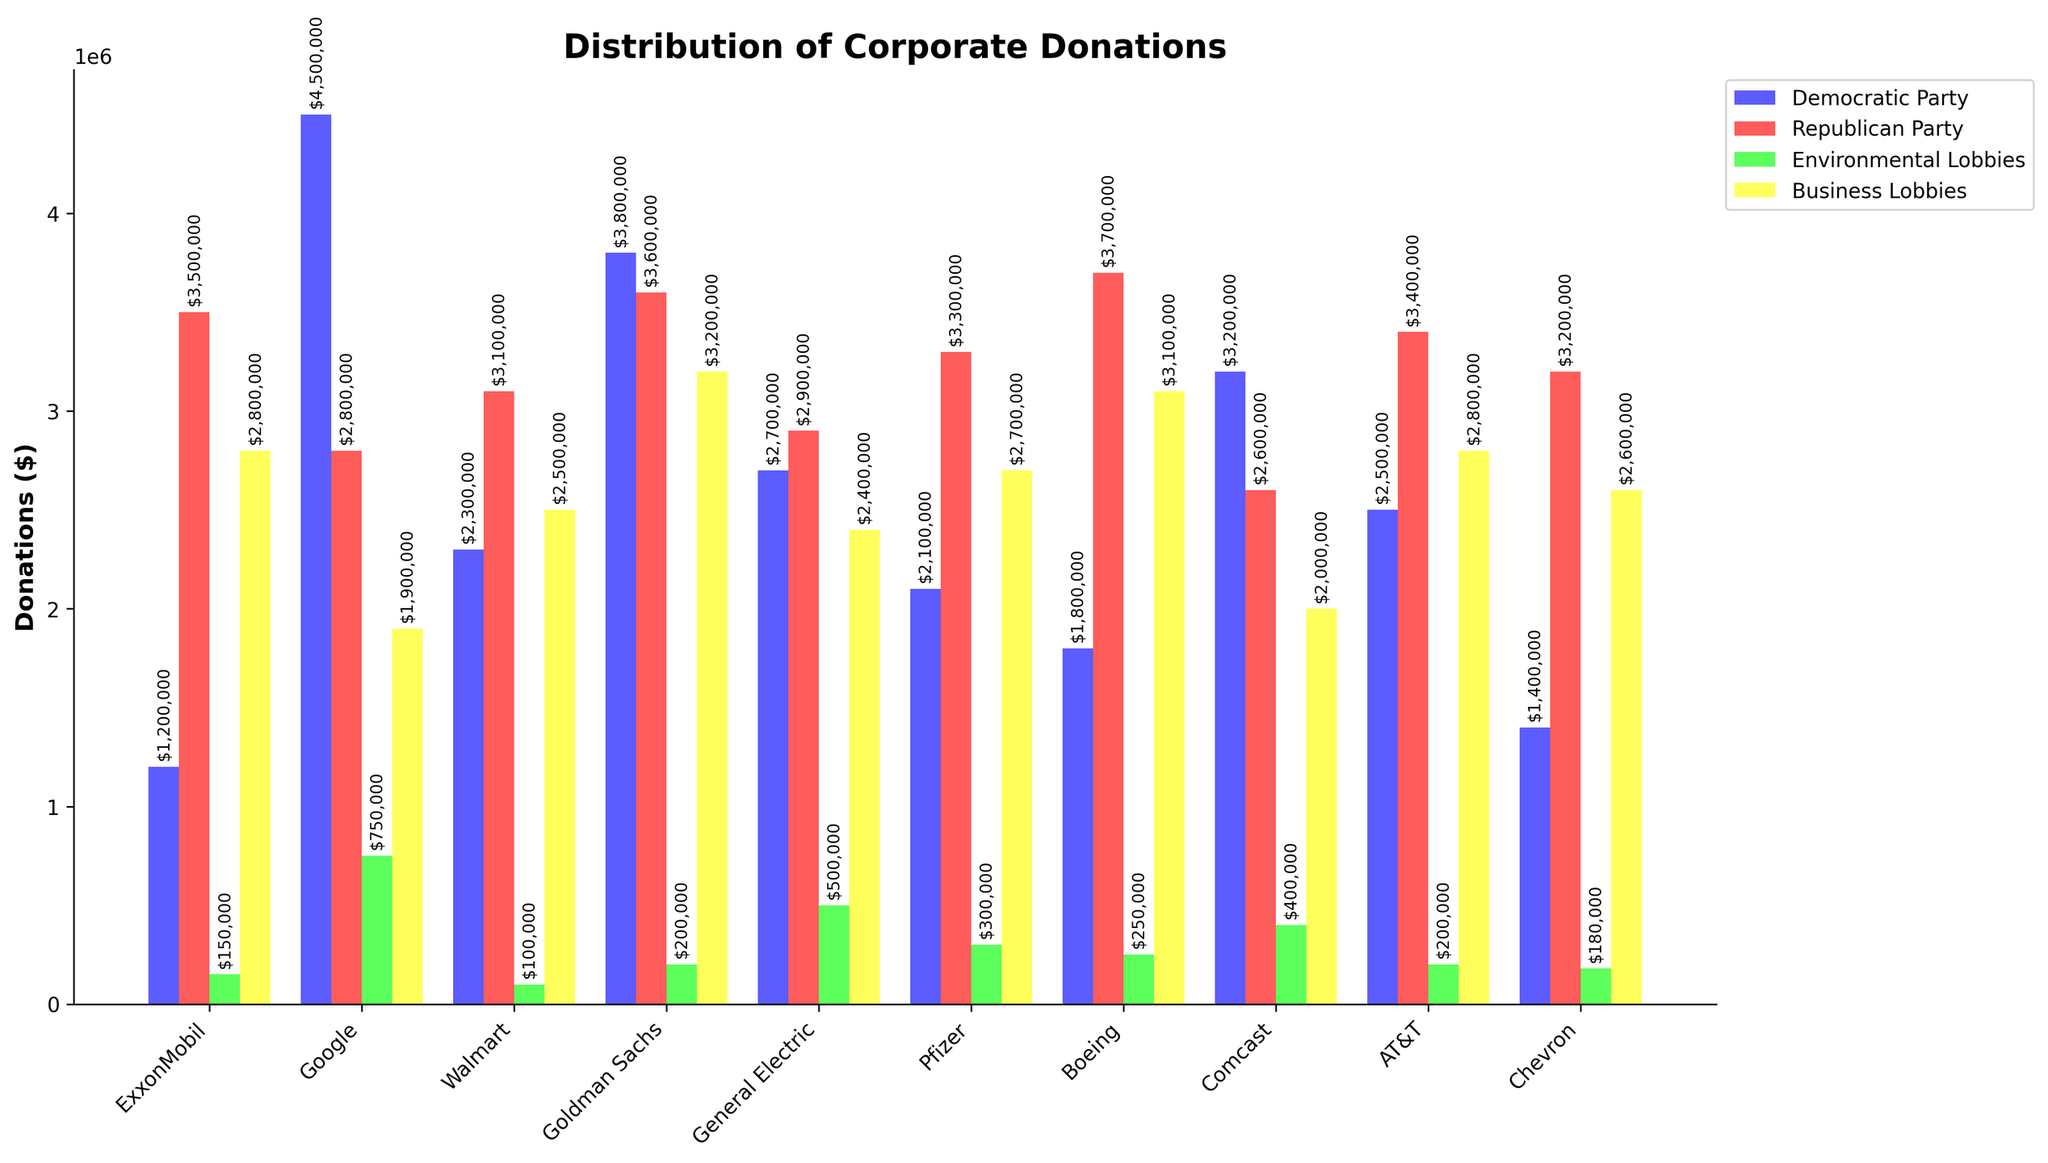What company donated the most to the Republican Party? Identify the bar corresponding to the "Republican Party" and compare their heights. The highest bar in this series belongs to Boeing.
Answer: Boeing Which company gave more to Business Lobbies compared to Democratic Party, and by how much? First, compare the heights of the bars for "Business Lobbies" and "Democratic Party" within each company. Then, calculate the difference where the "Business Lobbies" bar is taller. For AT&T: $2,800,000 (Business Lobbies) - $2,500,000 (Democratic Party) = $300,000.
Answer: AT&T, $300,000 What is the total donation amount that Google has made to all groups combined? Sum the heights of all bars corresponding to Google. $4,500,000 (Democratic Party) + $2,800,000 (Republican Party) + $750,000 (Environmental Lobbies) + $1,900,000 (Business Lobbies) = $9,950,000.
Answer: $9,950,000 Which company has the highest combined donation to Environmental Lobbies and Democratic Party? Sum the heights of the bars for "Environmental Lobbies" and "Democratic Party" for each company. The highest total is for Google: $4,500,000 (Democratic Party) + $750,000 (Environmental Lobbies) = $5,250,000.
Answer: Google How does Exxon's donation to Environmental Lobbies compare with that to Business Lobbies? Compare the heights of Exxon's bars for "Environmental Lobbies" and "Business Lobbies". The donation to Business Lobbies ($2,800,000) is substantially higher than to Environmental Lobbies ($150,000).
Answer: Exxon's Business Lobbies donation is much higher Which company donated the least to Environmental Lobbies? Identify the shortest bar in the "Environmental Lobbies" category. Walmart has the shortest bar at $100,000.
Answer: Walmart What is the average donation to the Republican Party among all companies? Sum the heights of all bars for "Republican Party", then divide by the number of companies. (35,000,000 / 10 companies = $3,250,000).
Answer: $3,250,000 Is there any company that donates equally to both the Democratic and Republican Parties? Compare the heights of “Democratic Party” and “Republican Party” bars for each company. If they match, the company is identified. Boss, no company donates the same amount to both parties from the given data.
Answer: No What is the difference in total political donations (sum of Democratic and Republican) between Boeing and Pfizer? Calculate the total for both: Boeing: $1,800,000 (Dem) + $3,700,000 (Rep) = $5,500,000; Pfizer: $2,100,000 (Dem) + $3,300,000 (Rep) = $5,400,000. Then find the difference: $5,500,000 - $5,400,000 = $100,000.
Answer: $100,000 Among all companies, which one donated the least to Business Lobbies? Identify the shortest bar for "Business Lobbies", compare their lengths to determine the smallest. The shortest bar is Comcast's, at $2,000,000.
Answer: Comcast 